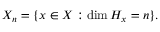<formula> <loc_0><loc_0><loc_500><loc_500>X _ { n } = \{ x \in X \colon \dim H _ { x } = n \} .</formula> 